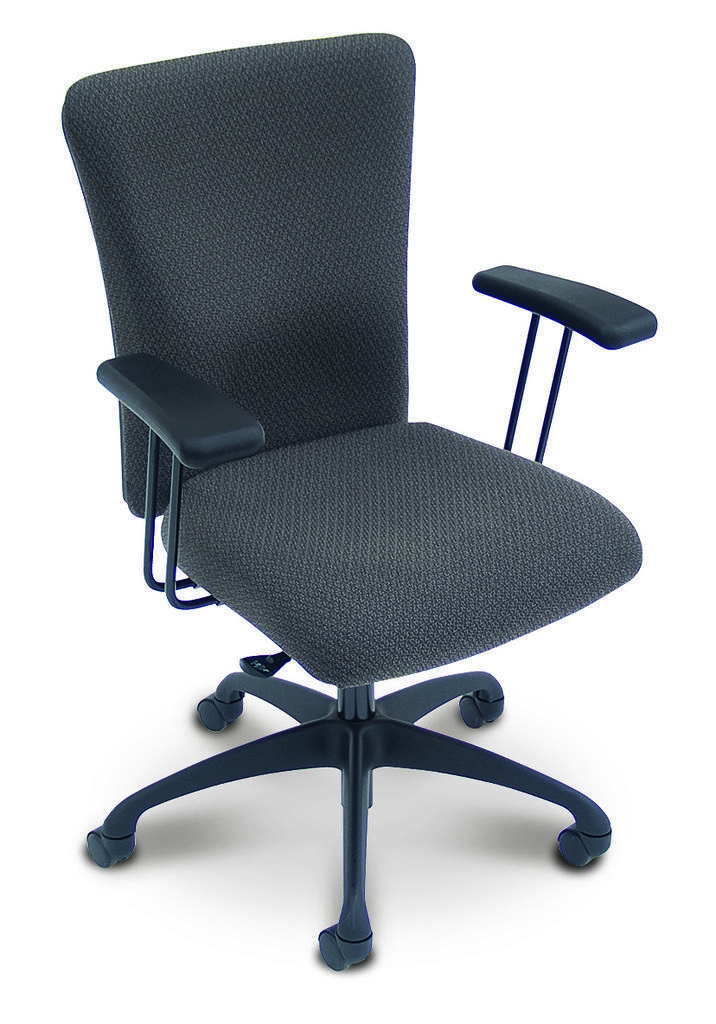Please provide a concise description of this image. In this picture I can see there is a chair and it has few wheels, armrest, it is in black color and is placed on a white surface. 